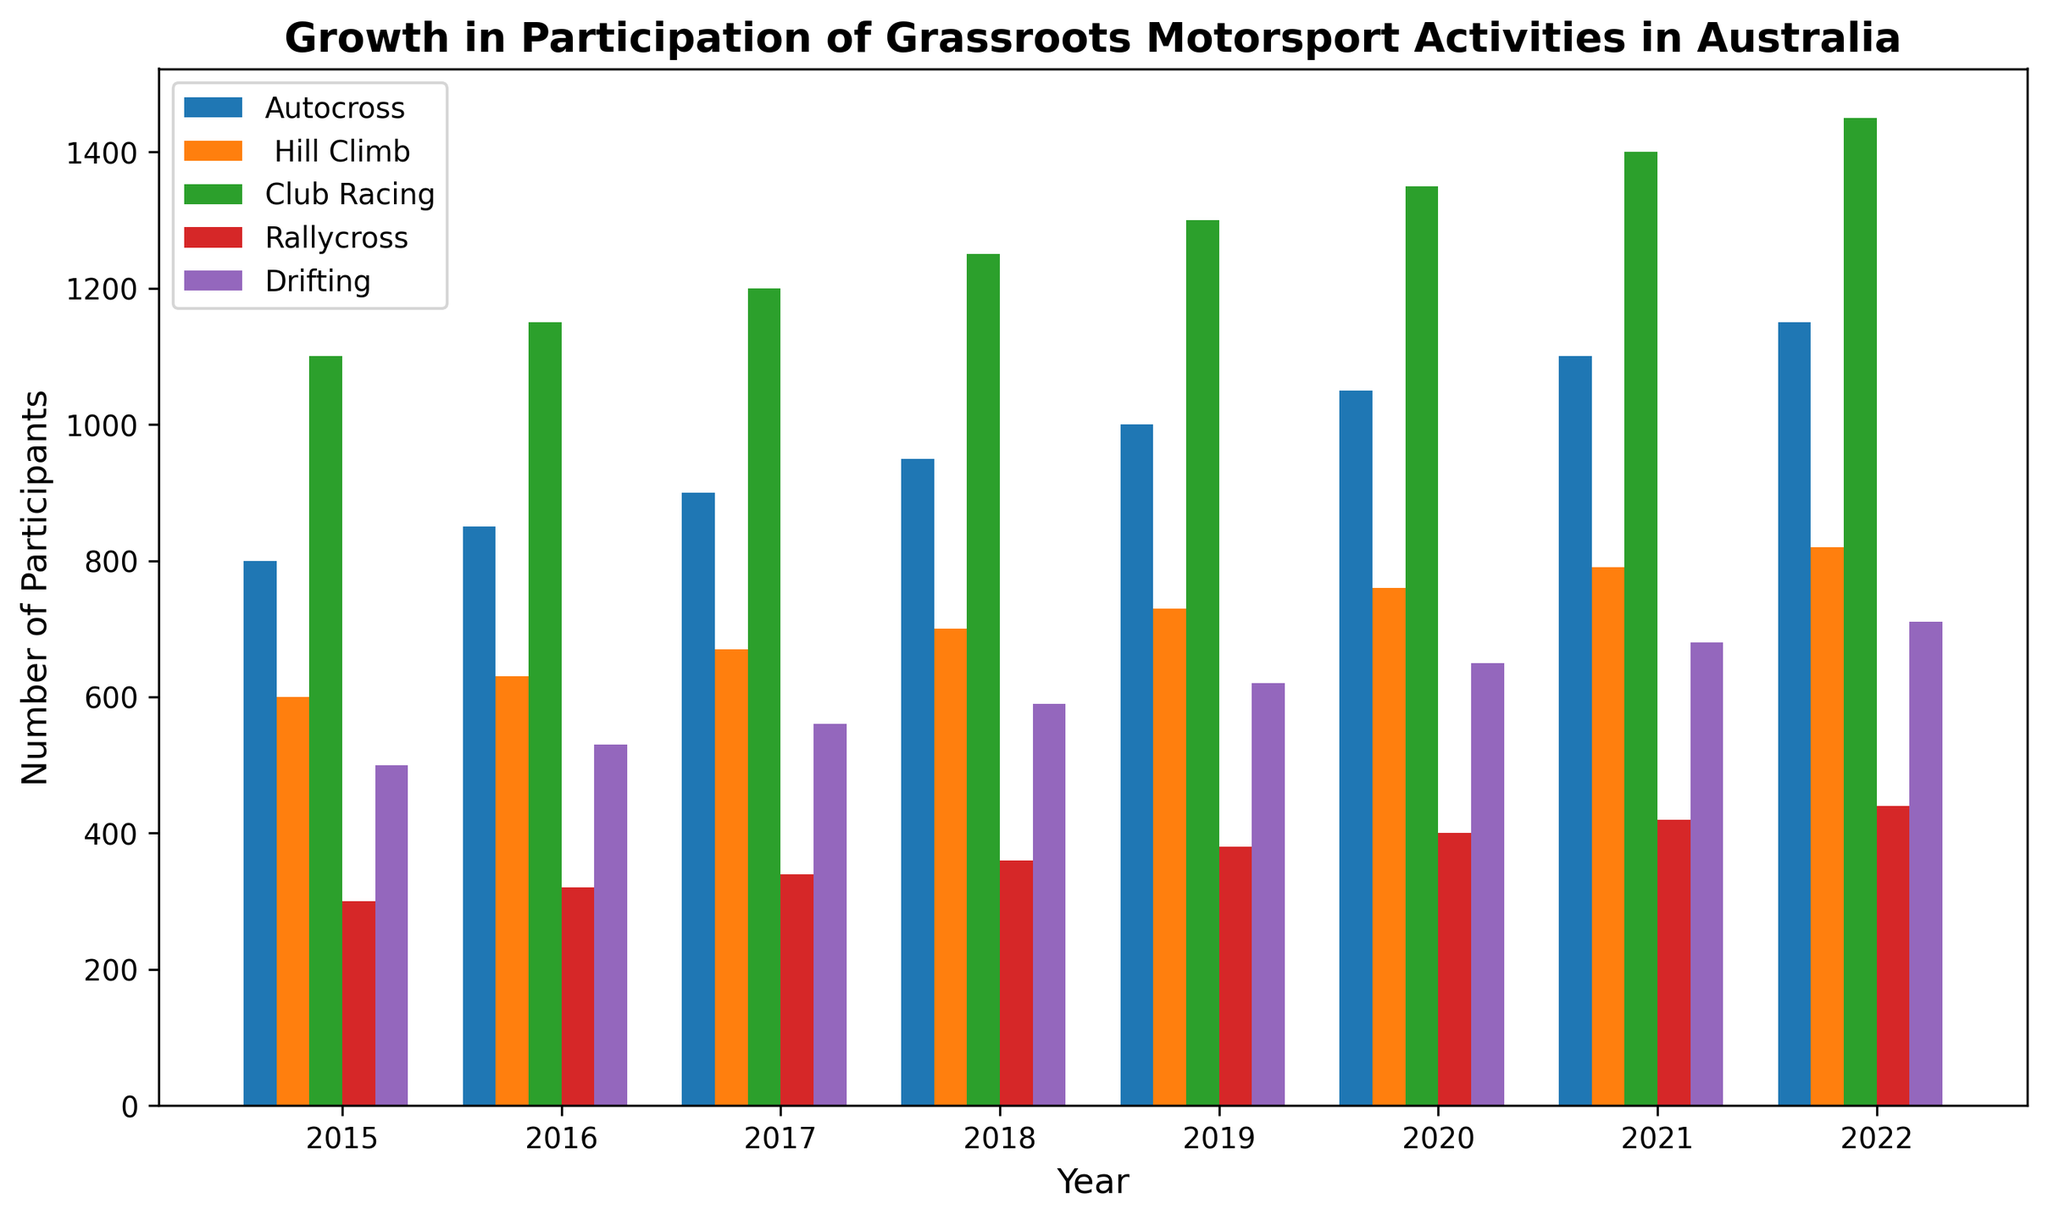Which activity had the highest number of participants in 2022? Look at the bar heights for 2022 on the chart, and identify the activity with the tallest bar. In 2022, Club Racing has the highest bar compared to the others.
Answer: Club Racing How many more participants were there in Autocross than in Rallycross in 2020? Find the bar heights for Autocross and Rallycross for 2020, then subtract the number of participants in Rallycross from those in Autocross. Autocross had 1050 participants, and Rallycross had 400 participants in 2020. The difference is 1050 - 400.
Answer: 650 What is the average number of participants in Drifting from 2015 to 2022? Find the bar heights for Drifting from 2015 to 2022, sum them up and divide by 8 (number of years). The values are 500, 530, 560, 590, 620, 650, 680, and 710. The sum is 4840, so the average is 4840/8.
Answer: 605 Which year had the largest increase in total participation across all activities compared to the previous year? Calculate the yearly total participation for all activities, then find the year with the largest difference compared to the previous year. For example,
2016: 850+630+1150+320+530 = 3480,
2017: 900+670+1200+340+560 = 3670,
Difference = 3670-3480 = 190. Repeat this process for each year and identify the maximum difference.
Answer: 2018 In which year did Hill Climb participation surpass 700? Look for the first year where the bar for Hill Climb crosses the 700 mark. Check the Hill Climb bar heights year by year: 2018 has 700 and 2019 has 730. The first surpassing year is 2019.
Answer: 2019 